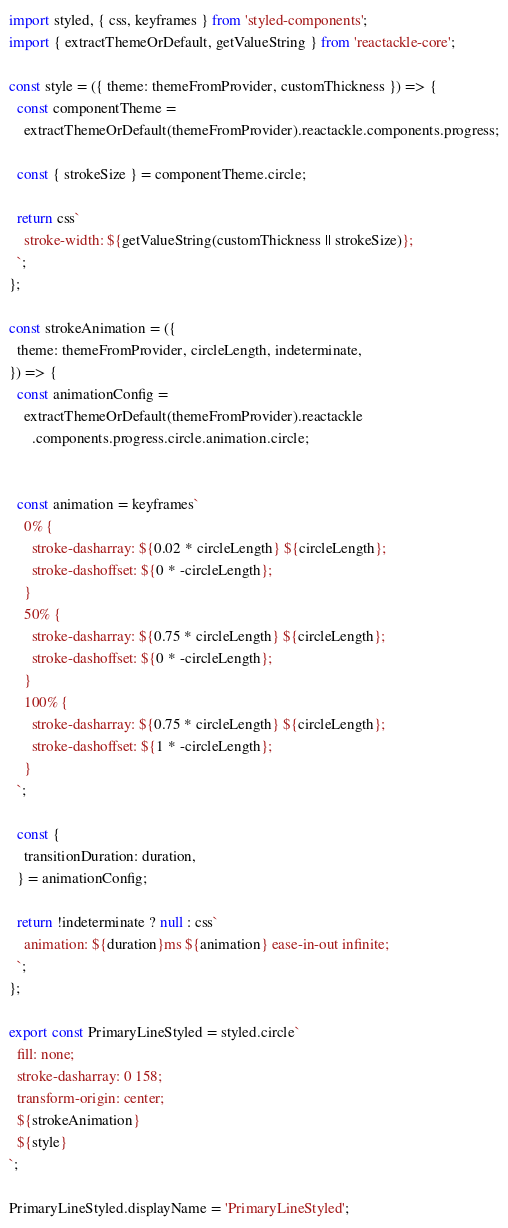Convert code to text. <code><loc_0><loc_0><loc_500><loc_500><_JavaScript_>import styled, { css, keyframes } from 'styled-components';
import { extractThemeOrDefault, getValueString } from 'reactackle-core';

const style = ({ theme: themeFromProvider, customThickness }) => {
  const componentTheme =
    extractThemeOrDefault(themeFromProvider).reactackle.components.progress;
  
  const { strokeSize } = componentTheme.circle;

  return css`
    stroke-width: ${getValueString(customThickness || strokeSize)};
  `;
};

const strokeAnimation = ({
  theme: themeFromProvider, circleLength, indeterminate,
}) => {
  const animationConfig =
    extractThemeOrDefault(themeFromProvider).reactackle
      .components.progress.circle.animation.circle;


  const animation = keyframes`
    0% {
      stroke-dasharray: ${0.02 * circleLength} ${circleLength};
      stroke-dashoffset: ${0 * -circleLength};
    }
    50% {
      stroke-dasharray: ${0.75 * circleLength} ${circleLength};
      stroke-dashoffset: ${0 * -circleLength};
    }
    100% {
      stroke-dasharray: ${0.75 * circleLength} ${circleLength};
      stroke-dashoffset: ${1 * -circleLength};
    }
  `;

  const {
    transitionDuration: duration,
  } = animationConfig;

  return !indeterminate ? null : css`
    animation: ${duration}ms ${animation} ease-in-out infinite;
  `;
};

export const PrimaryLineStyled = styled.circle`
  fill: none;
  stroke-dasharray: 0 158;
  transform-origin: center;
  ${strokeAnimation}
  ${style}
`;

PrimaryLineStyled.displayName = 'PrimaryLineStyled';
</code> 